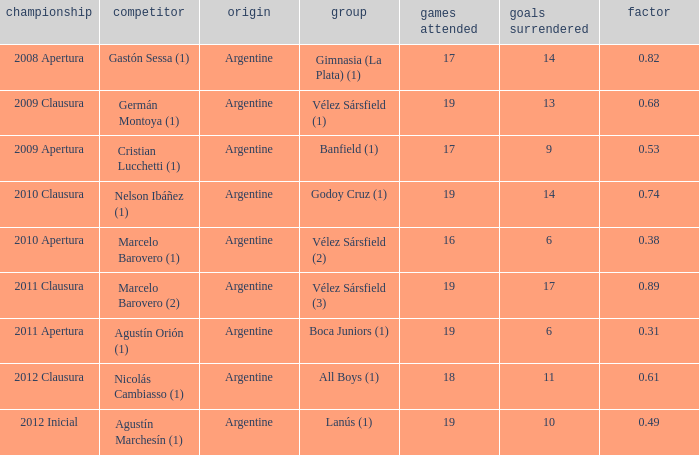What is the nationality of the 2012 clausura  tournament? Argentine. 